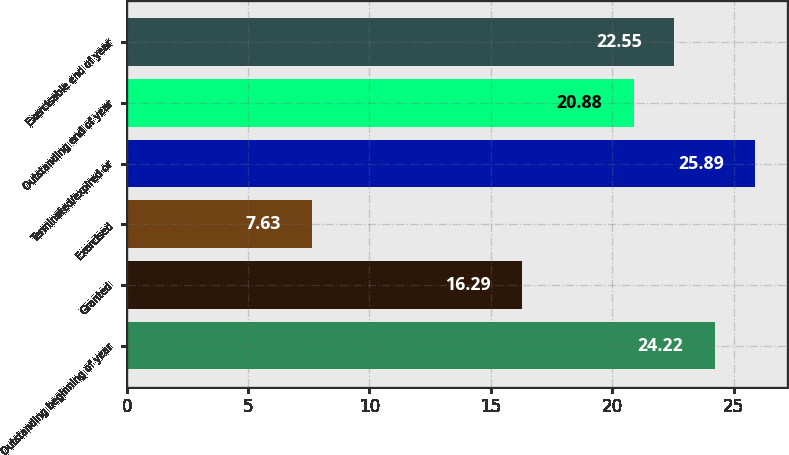Convert chart. <chart><loc_0><loc_0><loc_500><loc_500><bar_chart><fcel>Outstanding beginning of year<fcel>Granted<fcel>Exercised<fcel>Terminated/expired or<fcel>Outstanding end of year<fcel>Exercisable end of year<nl><fcel>24.22<fcel>16.29<fcel>7.63<fcel>25.89<fcel>20.88<fcel>22.55<nl></chart> 